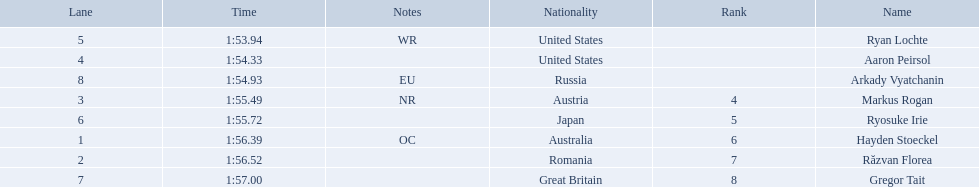What is the name of the contestant in lane 6? Ryosuke Irie. How long did it take that player to complete the race? 1:55.72. Parse the full table in json format. {'header': ['Lane', 'Time', 'Notes', 'Nationality', 'Rank', 'Name'], 'rows': [['5', '1:53.94', 'WR', 'United States', '', 'Ryan Lochte'], ['4', '1:54.33', '', 'United States', '', 'Aaron Peirsol'], ['8', '1:54.93', 'EU', 'Russia', '', 'Arkady Vyatchanin'], ['3', '1:55.49', 'NR', 'Austria', '4', 'Markus Rogan'], ['6', '1:55.72', '', 'Japan', '5', 'Ryosuke Irie'], ['1', '1:56.39', 'OC', 'Australia', '6', 'Hayden Stoeckel'], ['2', '1:56.52', '', 'Romania', '7', 'Răzvan Florea'], ['7', '1:57.00', '', 'Great Britain', '8', 'Gregor Tait']]} 